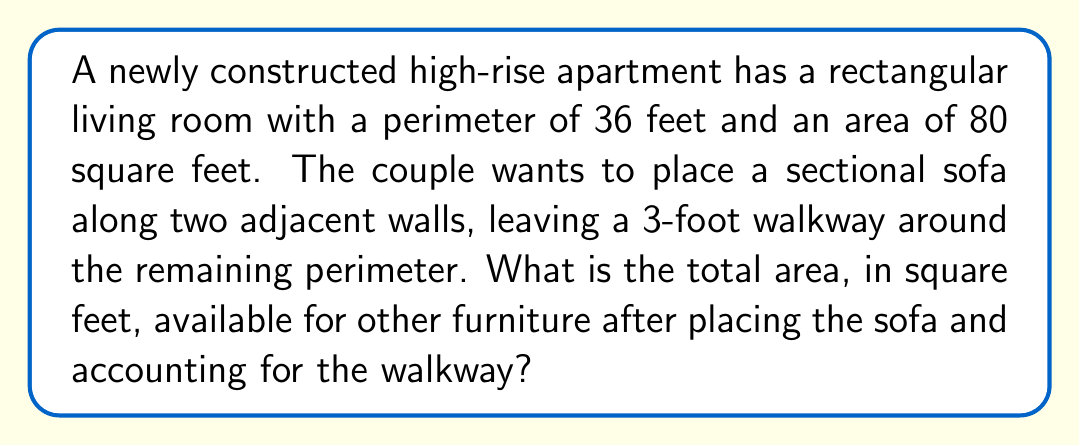Give your solution to this math problem. Let's approach this step-by-step:

1) First, we need to find the dimensions of the room. Let $l$ be the length and $w$ be the width.
   We know:
   Perimeter: $2l + 2w = 36$
   Area: $lw = 80$

2) From the perimeter equation:
   $l + w = 18$
   $w = 18 - l$

3) Substituting this into the area equation:
   $l(18 - l) = 80$
   $18l - l^2 = 80$
   $l^2 - 18l + 80 = 0$

4) This is a quadratic equation. Solving it:
   $l = \frac{18 \pm \sqrt{324 - 320}}{2} = \frac{18 \pm 2}{2}$
   $l = 10$ or $l = 8$

5) If $l = 10$, then $w = 8$. These are the room dimensions.

6) The 3-foot walkway around two sides reduces the usable area:
   New length: $10 - 3 = 7$
   New width: $8 - 3 = 5$
   Usable area: $7 * 5 = 35$ sq ft

7) The sectional sofa occupies two adjacent walls:
   Sofa area: $3 * 10 + 3 * 5 = 45$ sq ft

8) Total area available for other furniture:
   $80 - 35 - 45 = 0$ sq ft
Answer: 0 sq ft 